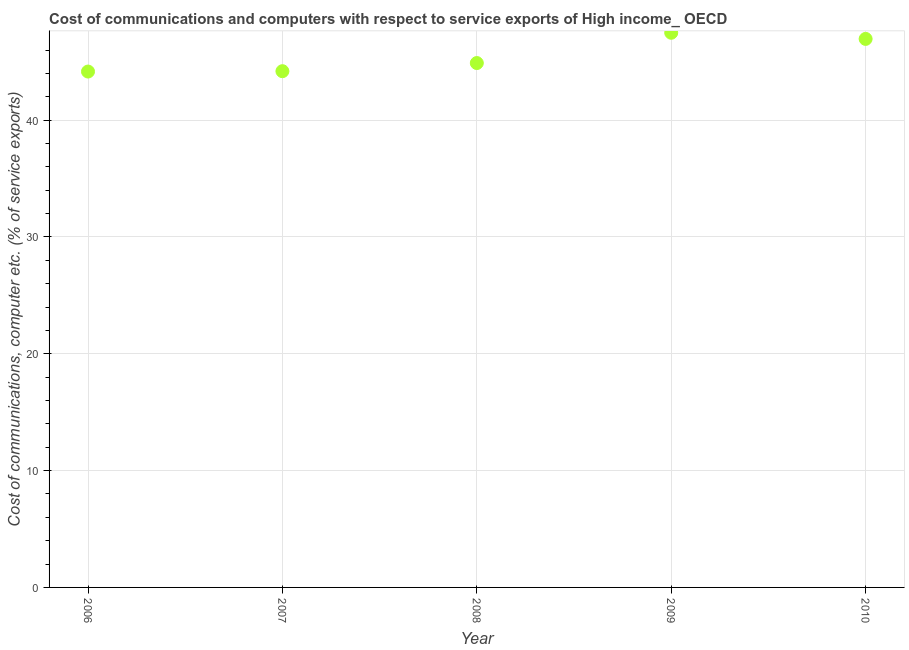What is the cost of communications and computer in 2010?
Give a very brief answer. 46.95. Across all years, what is the maximum cost of communications and computer?
Offer a very short reply. 47.48. Across all years, what is the minimum cost of communications and computer?
Your answer should be compact. 44.16. What is the sum of the cost of communications and computer?
Ensure brevity in your answer.  227.67. What is the difference between the cost of communications and computer in 2007 and 2010?
Provide a succinct answer. -2.76. What is the average cost of communications and computer per year?
Provide a short and direct response. 45.53. What is the median cost of communications and computer?
Your answer should be very brief. 44.89. Do a majority of the years between 2007 and 2006 (inclusive) have cost of communications and computer greater than 14 %?
Offer a terse response. No. What is the ratio of the cost of communications and computer in 2006 to that in 2010?
Offer a very short reply. 0.94. Is the cost of communications and computer in 2006 less than that in 2009?
Offer a terse response. Yes. What is the difference between the highest and the second highest cost of communications and computer?
Provide a short and direct response. 0.53. Is the sum of the cost of communications and computer in 2006 and 2008 greater than the maximum cost of communications and computer across all years?
Ensure brevity in your answer.  Yes. What is the difference between the highest and the lowest cost of communications and computer?
Keep it short and to the point. 3.32. In how many years, is the cost of communications and computer greater than the average cost of communications and computer taken over all years?
Keep it short and to the point. 2. Does the cost of communications and computer monotonically increase over the years?
Your answer should be compact. No. How many dotlines are there?
Offer a very short reply. 1. How many years are there in the graph?
Offer a very short reply. 5. Are the values on the major ticks of Y-axis written in scientific E-notation?
Offer a very short reply. No. Does the graph contain any zero values?
Offer a very short reply. No. What is the title of the graph?
Ensure brevity in your answer.  Cost of communications and computers with respect to service exports of High income_ OECD. What is the label or title of the X-axis?
Ensure brevity in your answer.  Year. What is the label or title of the Y-axis?
Keep it short and to the point. Cost of communications, computer etc. (% of service exports). What is the Cost of communications, computer etc. (% of service exports) in 2006?
Make the answer very short. 44.16. What is the Cost of communications, computer etc. (% of service exports) in 2007?
Your answer should be compact. 44.19. What is the Cost of communications, computer etc. (% of service exports) in 2008?
Provide a short and direct response. 44.89. What is the Cost of communications, computer etc. (% of service exports) in 2009?
Provide a short and direct response. 47.48. What is the Cost of communications, computer etc. (% of service exports) in 2010?
Your answer should be very brief. 46.95. What is the difference between the Cost of communications, computer etc. (% of service exports) in 2006 and 2007?
Give a very brief answer. -0.03. What is the difference between the Cost of communications, computer etc. (% of service exports) in 2006 and 2008?
Your response must be concise. -0.73. What is the difference between the Cost of communications, computer etc. (% of service exports) in 2006 and 2009?
Provide a succinct answer. -3.32. What is the difference between the Cost of communications, computer etc. (% of service exports) in 2006 and 2010?
Offer a terse response. -2.79. What is the difference between the Cost of communications, computer etc. (% of service exports) in 2007 and 2008?
Offer a very short reply. -0.7. What is the difference between the Cost of communications, computer etc. (% of service exports) in 2007 and 2009?
Keep it short and to the point. -3.29. What is the difference between the Cost of communications, computer etc. (% of service exports) in 2007 and 2010?
Your response must be concise. -2.76. What is the difference between the Cost of communications, computer etc. (% of service exports) in 2008 and 2009?
Give a very brief answer. -2.59. What is the difference between the Cost of communications, computer etc. (% of service exports) in 2008 and 2010?
Ensure brevity in your answer.  -2.07. What is the difference between the Cost of communications, computer etc. (% of service exports) in 2009 and 2010?
Make the answer very short. 0.53. What is the ratio of the Cost of communications, computer etc. (% of service exports) in 2006 to that in 2008?
Offer a very short reply. 0.98. What is the ratio of the Cost of communications, computer etc. (% of service exports) in 2007 to that in 2009?
Your answer should be very brief. 0.93. What is the ratio of the Cost of communications, computer etc. (% of service exports) in 2007 to that in 2010?
Make the answer very short. 0.94. What is the ratio of the Cost of communications, computer etc. (% of service exports) in 2008 to that in 2009?
Provide a succinct answer. 0.94. What is the ratio of the Cost of communications, computer etc. (% of service exports) in 2008 to that in 2010?
Your answer should be compact. 0.96. What is the ratio of the Cost of communications, computer etc. (% of service exports) in 2009 to that in 2010?
Offer a terse response. 1.01. 